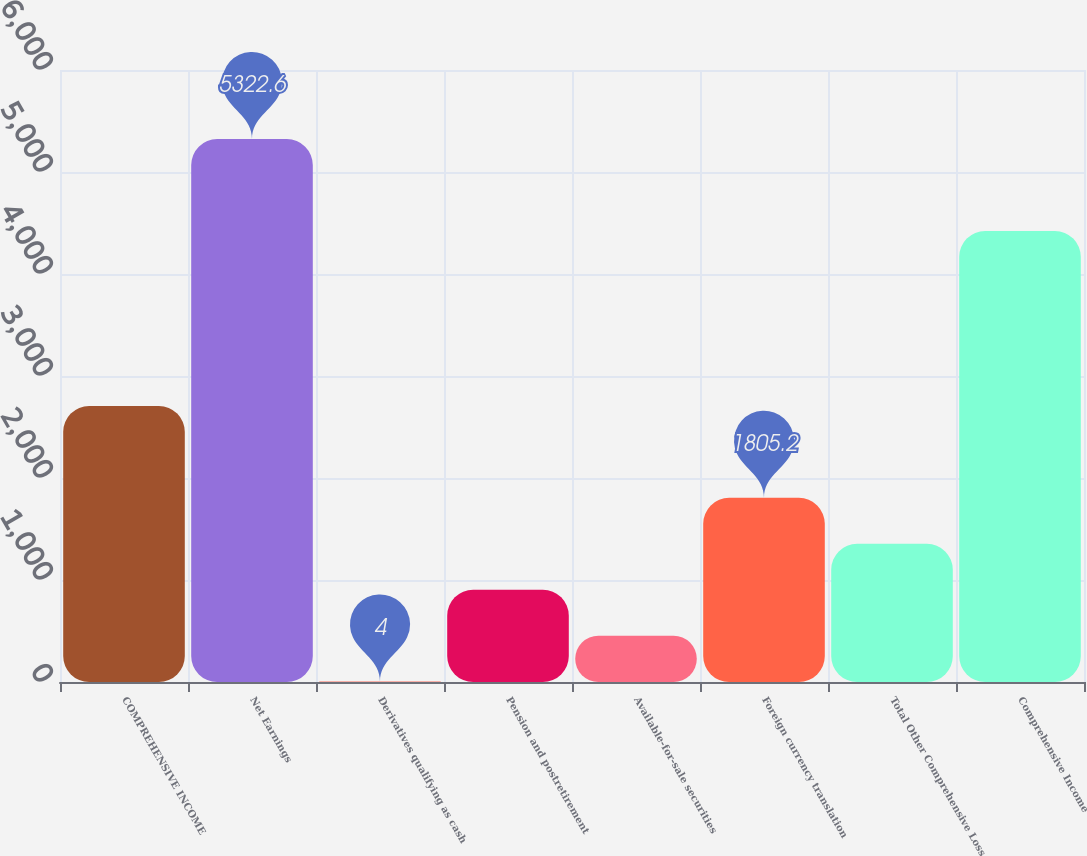Convert chart. <chart><loc_0><loc_0><loc_500><loc_500><bar_chart><fcel>COMPREHENSIVE INCOME<fcel>Net Earnings<fcel>Derivatives qualifying as cash<fcel>Pension and postretirement<fcel>Available-for-sale securities<fcel>Foreign currency translation<fcel>Total Other Comprehensive Loss<fcel>Comprehensive Income<nl><fcel>2705.8<fcel>5322.6<fcel>4<fcel>904.6<fcel>454.3<fcel>1805.2<fcel>1354.9<fcel>4422<nl></chart> 